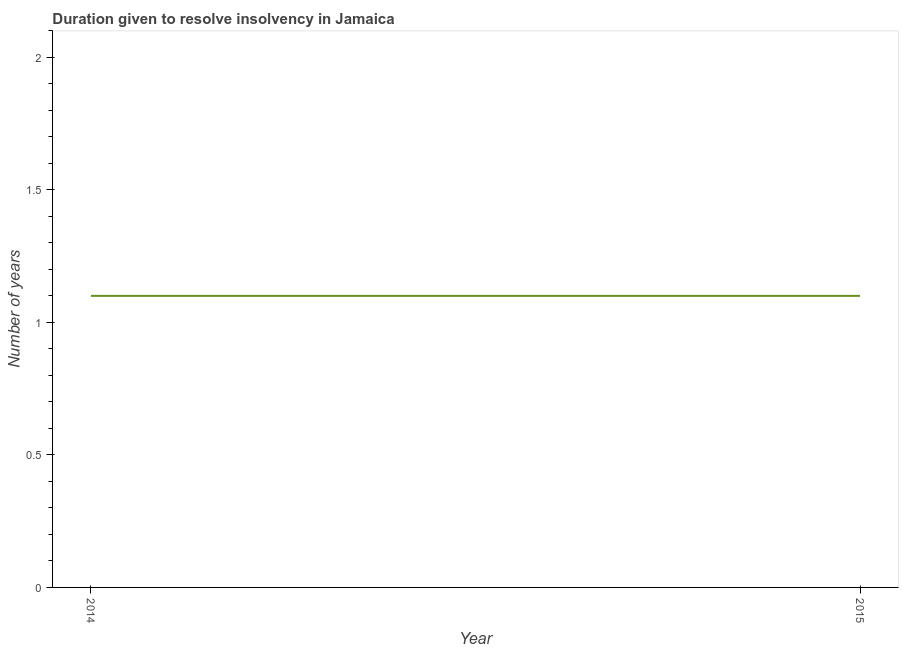What is the number of years to resolve insolvency in 2015?
Your answer should be compact. 1.1. What is the difference between the number of years to resolve insolvency in 2014 and 2015?
Make the answer very short. 0. What is the median number of years to resolve insolvency?
Make the answer very short. 1.1. Do a majority of the years between 2015 and 2014 (inclusive) have number of years to resolve insolvency greater than 1 ?
Provide a succinct answer. No. In how many years, is the number of years to resolve insolvency greater than the average number of years to resolve insolvency taken over all years?
Your answer should be compact. 0. How many lines are there?
Your response must be concise. 1. How many years are there in the graph?
Give a very brief answer. 2. Are the values on the major ticks of Y-axis written in scientific E-notation?
Provide a short and direct response. No. What is the title of the graph?
Provide a short and direct response. Duration given to resolve insolvency in Jamaica. What is the label or title of the X-axis?
Give a very brief answer. Year. What is the label or title of the Y-axis?
Make the answer very short. Number of years. What is the Number of years in 2014?
Make the answer very short. 1.1. What is the difference between the Number of years in 2014 and 2015?
Provide a short and direct response. 0. What is the ratio of the Number of years in 2014 to that in 2015?
Give a very brief answer. 1. 